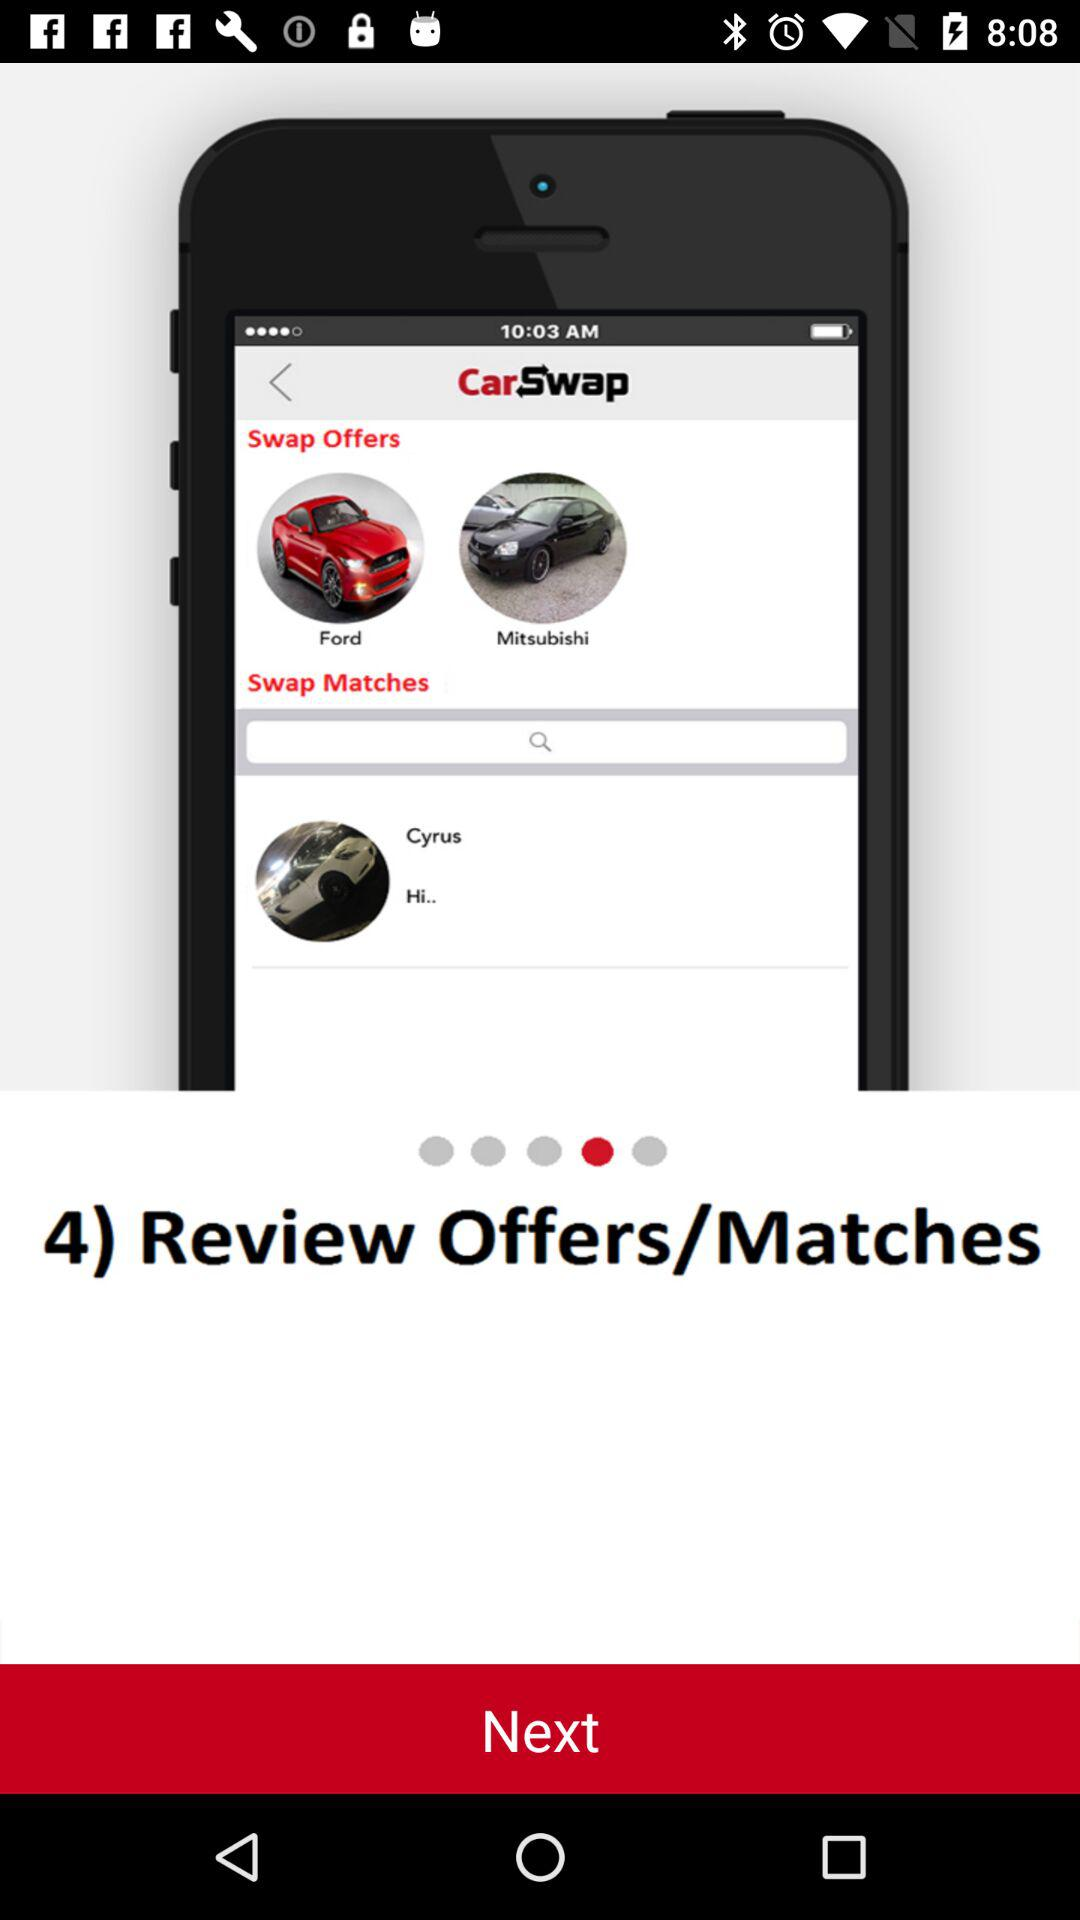What option is there on number 4? The option is "Review Offers/Matches". 